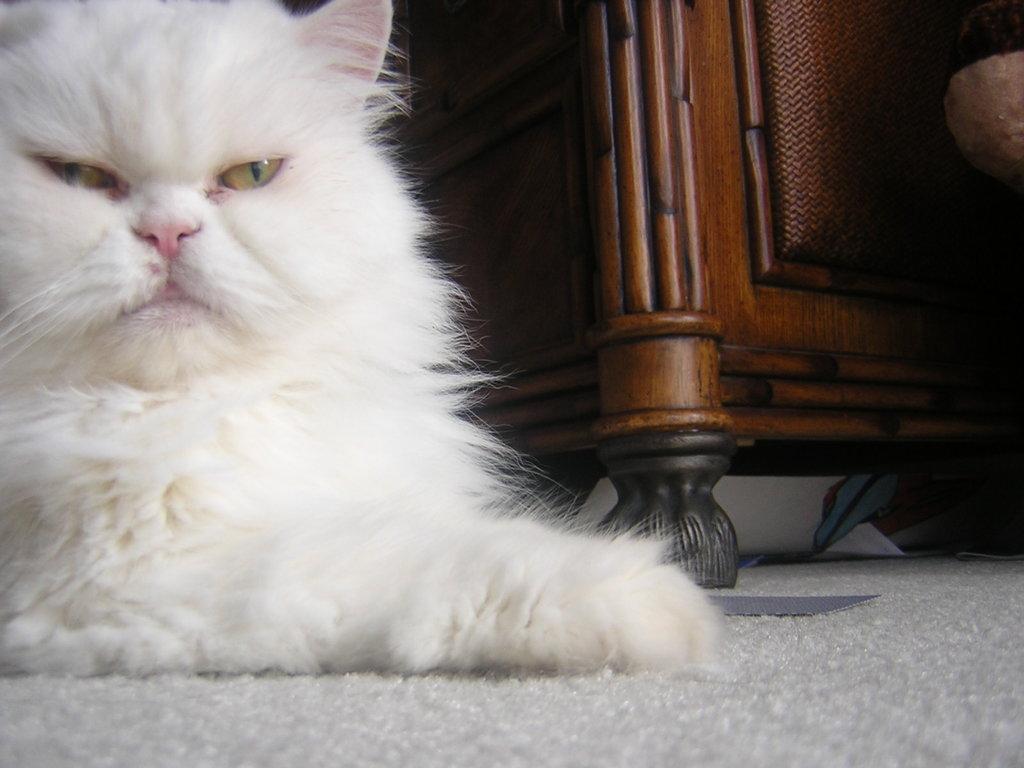Can you describe this image briefly? In this image in the center on the left side there is Cat which is white in colour. On the right side there is a wooden object. 